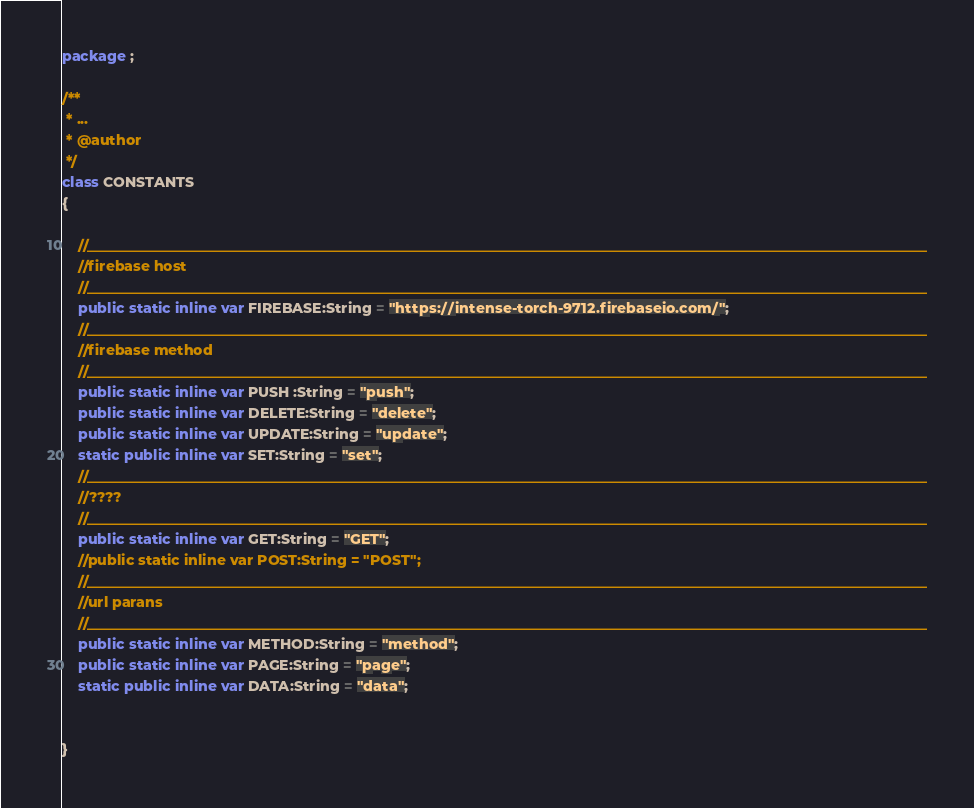Convert code to text. <code><loc_0><loc_0><loc_500><loc_500><_Haxe_>package ;

/**
 * ...
 * @author 
 */
class CONSTANTS
{

	//________________________________________________________________________________________________________________________
	//firebase host
	//________________________________________________________________________________________________________________________
	public static inline var FIREBASE:String = "https://intense-torch-9712.firebaseio.com/";
	//________________________________________________________________________________________________________________________
	//firebase method
	//________________________________________________________________________________________________________________________
	public static inline var PUSH :String = "push";
	public static inline var DELETE:String = "delete";
	public static inline var UPDATE:String = "update";
	static public inline var SET:String = "set";
	//________________________________________________________________________________________________________________________
	//????
	//________________________________________________________________________________________________________________________
	public static inline var GET:String = "GET";
	//public static inline var POST:String = "POST";
	//________________________________________________________________________________________________________________________
	//url parans
	//________________________________________________________________________________________________________________________
	public static inline var METHOD:String = "method";
	public static inline var PAGE:String = "page";	
	static public inline var DATA:String = "data";
	
	
}</code> 